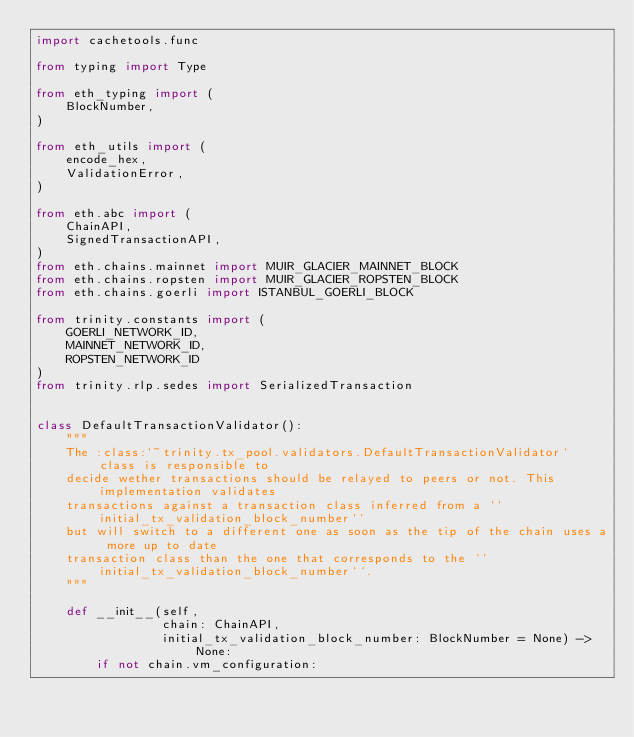Convert code to text. <code><loc_0><loc_0><loc_500><loc_500><_Python_>import cachetools.func

from typing import Type

from eth_typing import (
    BlockNumber,
)

from eth_utils import (
    encode_hex,
    ValidationError,
)

from eth.abc import (
    ChainAPI,
    SignedTransactionAPI,
)
from eth.chains.mainnet import MUIR_GLACIER_MAINNET_BLOCK
from eth.chains.ropsten import MUIR_GLACIER_ROPSTEN_BLOCK
from eth.chains.goerli import ISTANBUL_GOERLI_BLOCK

from trinity.constants import (
    GOERLI_NETWORK_ID,
    MAINNET_NETWORK_ID,
    ROPSTEN_NETWORK_ID
)
from trinity.rlp.sedes import SerializedTransaction


class DefaultTransactionValidator():
    """
    The :class:`~trinity.tx_pool.validators.DefaultTransactionValidator` class is responsible to
    decide wether transactions should be relayed to peers or not. This implementation validates
    transactions against a transaction class inferred from a ``initial_tx_validation_block_number``
    but will switch to a different one as soon as the tip of the chain uses a more up to date
    transaction class than the one that corresponds to the ``initial_tx_validation_block_number``.
    """

    def __init__(self,
                 chain: ChainAPI,
                 initial_tx_validation_block_number: BlockNumber = None) -> None:
        if not chain.vm_configuration:</code> 